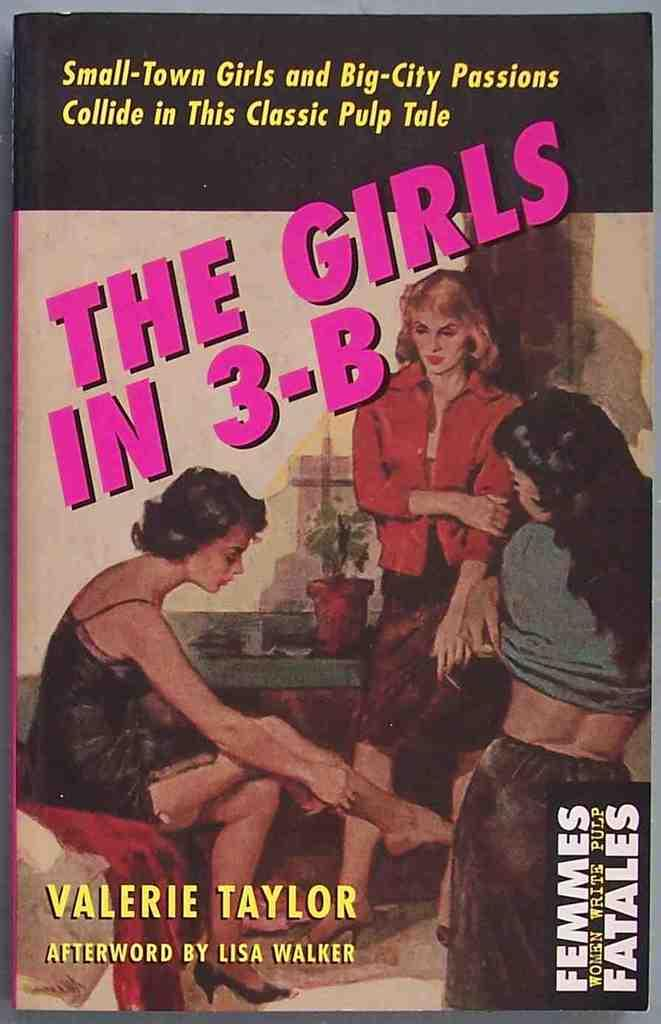<image>
Give a short and clear explanation of the subsequent image. A cover of a book showing three girls called The Girls In 3-B. 